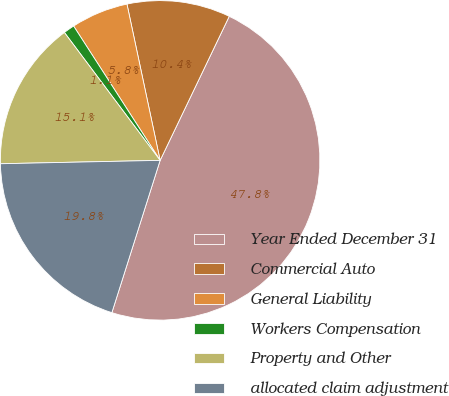<chart> <loc_0><loc_0><loc_500><loc_500><pie_chart><fcel>Year Ended December 31<fcel>Commercial Auto<fcel>General Liability<fcel>Workers Compensation<fcel>Property and Other<fcel>allocated claim adjustment<nl><fcel>47.77%<fcel>10.45%<fcel>5.78%<fcel>1.12%<fcel>15.11%<fcel>19.78%<nl></chart> 